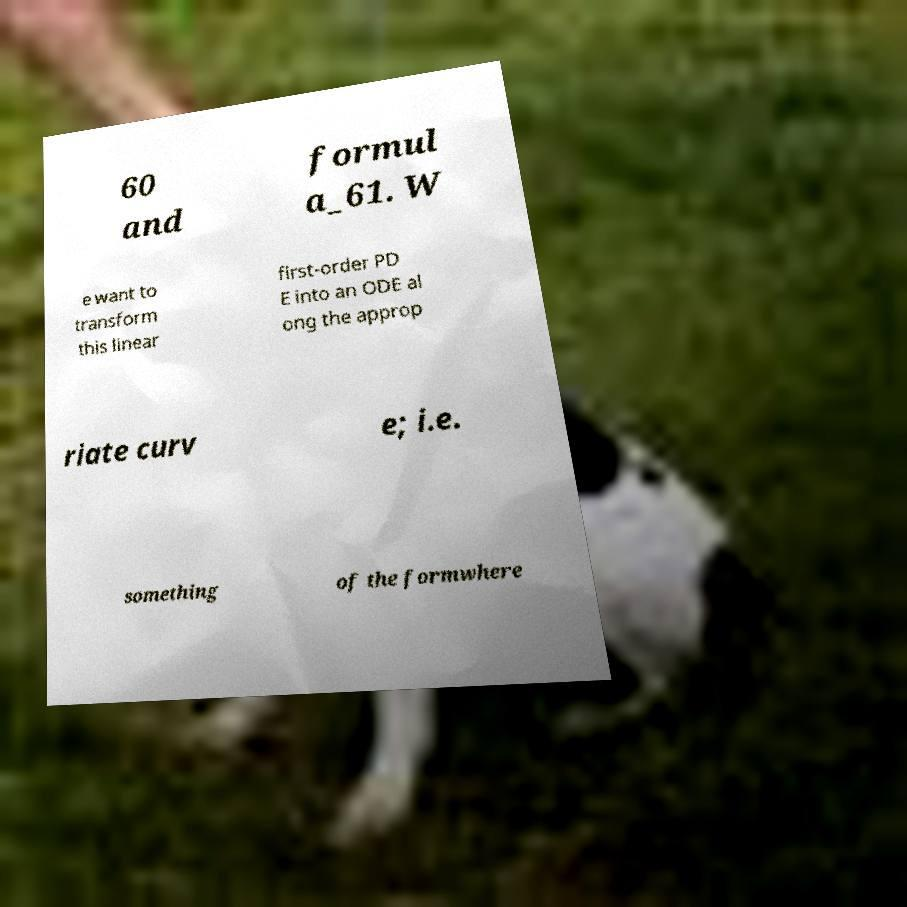What messages or text are displayed in this image? I need them in a readable, typed format. 60 and formul a_61. W e want to transform this linear first-order PD E into an ODE al ong the approp riate curv e; i.e. something of the formwhere 